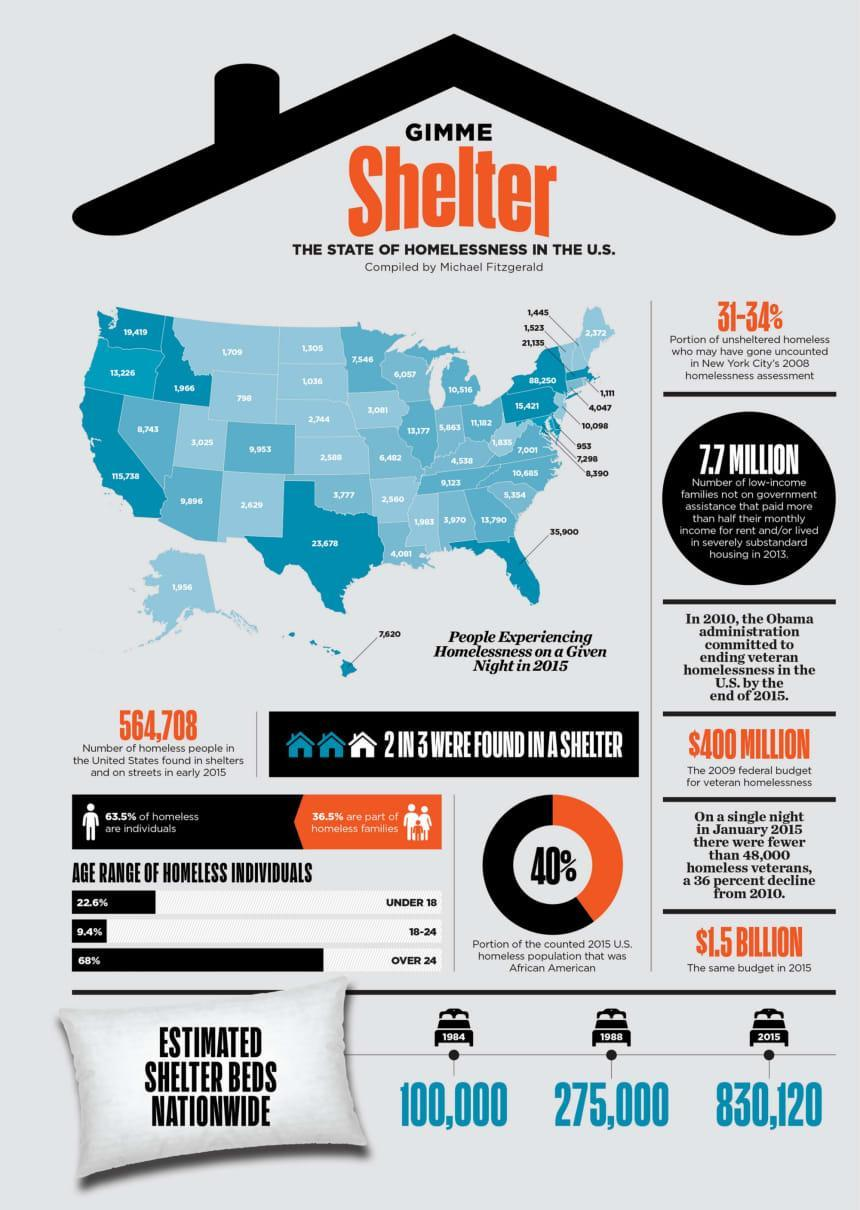What is the no of homeless people in the U.S. found in shelters and on streets in early 2015?
Answer the question with a short phrase. 564,708 What was the estimated shelter beds for homeless individuals nationwide in 1984? 100,000 What is the estimated shelter beds for homeless individuals nationwide in 2015? 830,120 What percent of the counted 2015 U.S. homeless population was African Aamerican? 40% What percentage of homeless individuals in U.S. are over 24? 68% What is the 2009 federal budget estimate for veteran homelessness in the U.S.? $400 Million Which age group has recorded 9.4% of homeless individuals in the U.S.? 18-24 